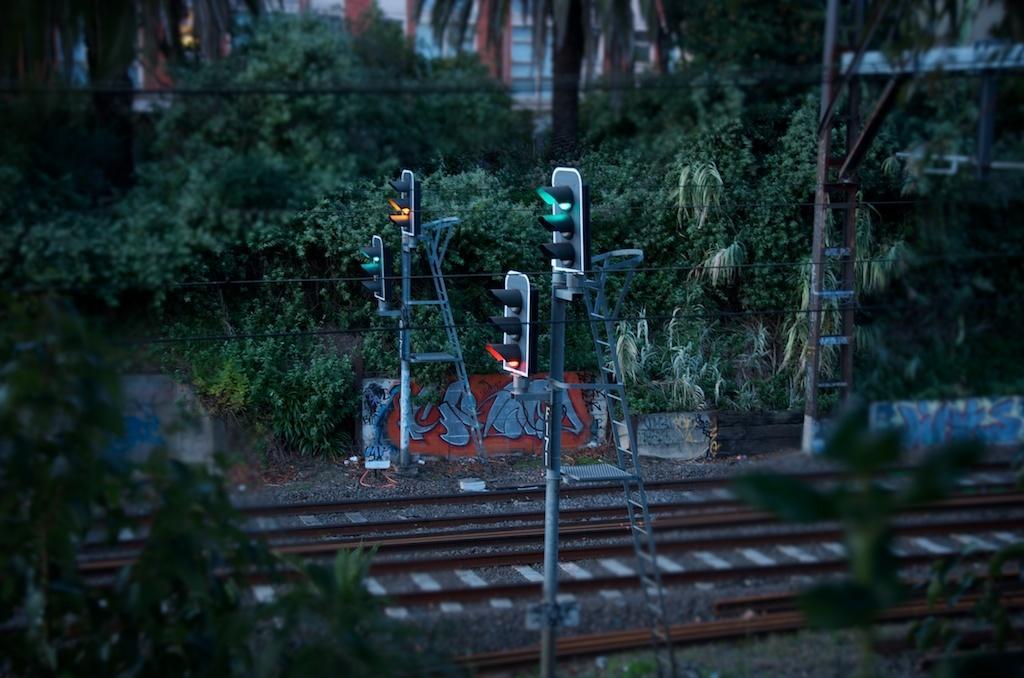How would you summarize this image in a sentence or two? In this image we can see some traffic lights, poles, ladders, there are paintings on the wall, there are trees, train tracks, wires, also we can see houses. 